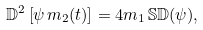Convert formula to latex. <formula><loc_0><loc_0><loc_500><loc_500>\mathbb { D } ^ { 2 } \left [ \psi \, m _ { 2 } ( t ) \right ] = 4 m _ { 1 } \, \mathbb { S } \mathbb { D } ( \psi ) ,</formula> 